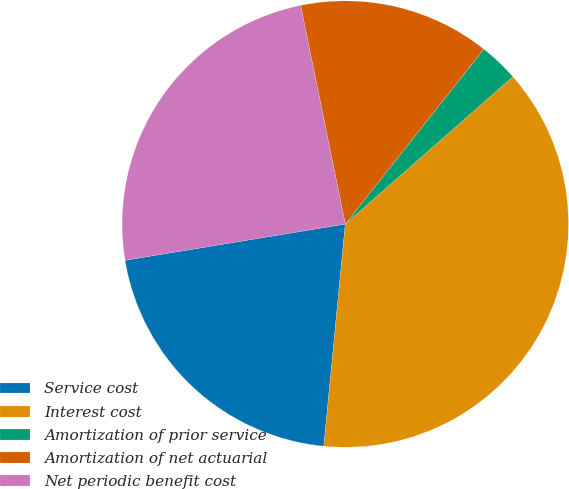Convert chart to OTSL. <chart><loc_0><loc_0><loc_500><loc_500><pie_chart><fcel>Service cost<fcel>Interest cost<fcel>Amortization of prior service<fcel>Amortization of net actuarial<fcel>Net periodic benefit cost<nl><fcel>20.87%<fcel>38.02%<fcel>2.86%<fcel>13.87%<fcel>24.39%<nl></chart> 